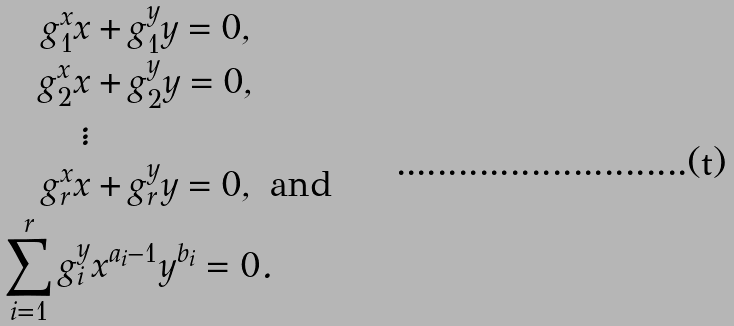<formula> <loc_0><loc_0><loc_500><loc_500>g _ { 1 } ^ { x } x & + g _ { 1 } ^ { y } y = 0 , \\ g _ { 2 } ^ { x } x & + g _ { 2 } ^ { y } y = 0 , \\ \vdots \\ g _ { r } ^ { x } x & + g _ { r } ^ { y } y = 0 , \text { and} \\ \sum _ { i = 1 } ^ { r } g _ { i } ^ { y } & x ^ { a _ { i } - 1 } y ^ { b _ { i } } = 0 .</formula> 